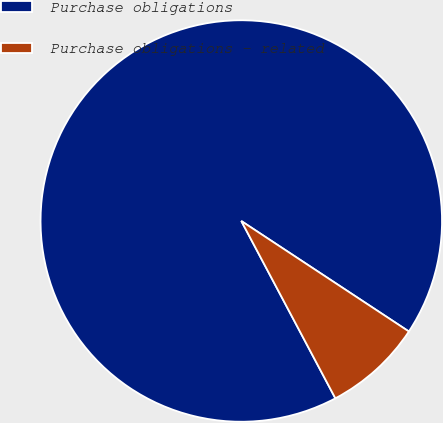Convert chart to OTSL. <chart><loc_0><loc_0><loc_500><loc_500><pie_chart><fcel>Purchase obligations<fcel>Purchase obligations - related<nl><fcel>92.04%<fcel>7.96%<nl></chart> 